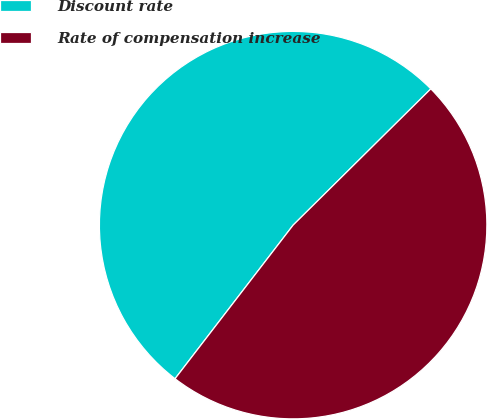<chart> <loc_0><loc_0><loc_500><loc_500><pie_chart><fcel>Discount rate<fcel>Rate of compensation increase<nl><fcel>52.15%<fcel>47.85%<nl></chart> 